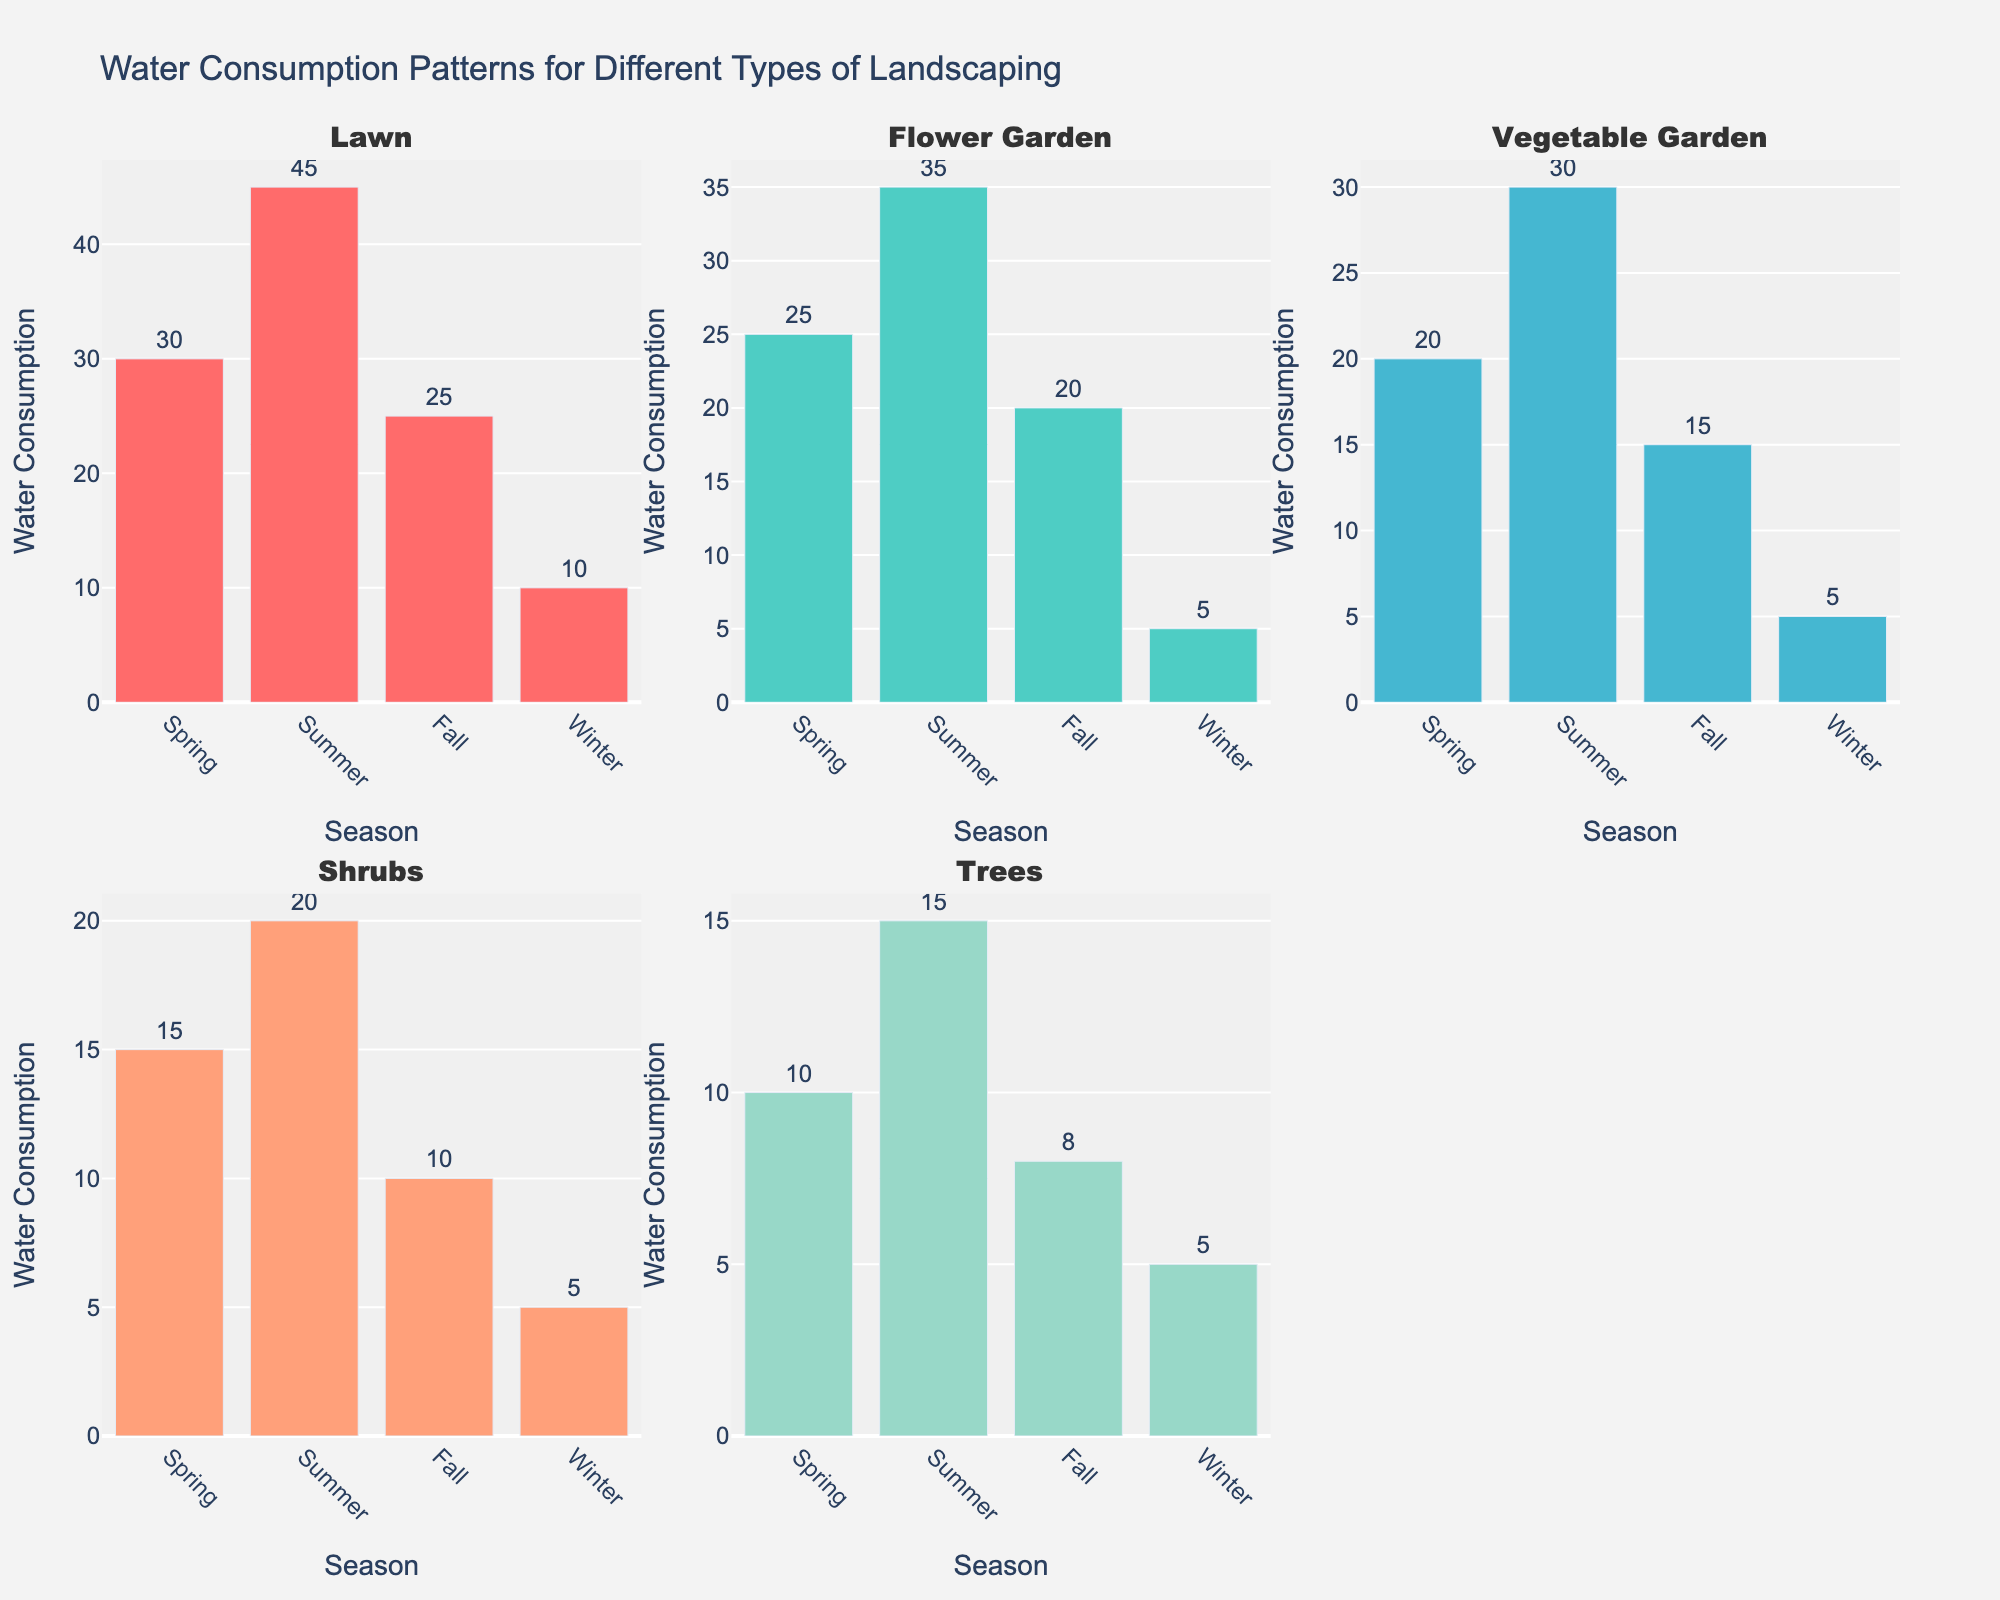What's the title of the figure? The title of the figure is written at the top of the plot and provides an overview of what the figure represents.
Answer: Conviction Rates: Undercover vs Standard Arrests Which crime type has the highest undercover conviction rate? Look at each subplot representing different crime types and identify which has the highest bar for undercover conviction rates. This is Terrorism with a rate of 88%.
Answer: Terrorism Which crime type has the lowest standard arrest conviction rate? Examine the bars representing standard arrest conviction rates in each subplot and find the smallest value. This is Cybercrime with a rate of 55%.
Answer: Cybercrime On average, are conviction rates higher for undercover operations or standard arrests? Look at the heights of the bars in each subplot. Compare the average height of bars for undercover operations to those for standard arrests across all crime types. Undercover conviction rates are consistently higher.
Answer: Undercover operations What's the difference in conviction rates between undercover and standard arrests for Human Trafficking? Look at the subplot for Human Trafficking and subtract the standard arrest conviction rate from the undercover conviction rate (0.80 - 0.58).
Answer: 0.22 or 22% Which crime type has the smallest difference in conviction rates between undercover operations and standard arrests? For each subplot, subtract the standard arrest conviction rate from the undercover conviction rate. The crime type with the lowest difference is Weapons Offenses with a difference of 0.06.
Answer: Weapons Offenses How many crime types have a higher conviction rate for undercover operations compared to standard arrests? Count the number of subplots where the undercover conviction rate bar is higher than the standard arrest conviction rate bar. All subplots fit this criterion, so there are 10 crime types.
Answer: 10 Which crime type shows the largest conviction rate improvement when using undercover operations compared to standard arrests? Calculate the differences for each crime type by subtracting the standard arrest conviction rate from the undercover conviction rate. The highest difference is for Organized Crime with an improvement of 0.25.
Answer: Organized Crime Is there any crime type where standard arrests have a higher conviction rate than undercover operations? Scan through each subplot and compare the heights of the bars. There is no subplot where the standard arrest conviction rate bar is higher than the undercover conviction rate bar.
Answer: No What is the range of standard arrest conviction rates across all crime types? Identify the minimum and maximum values of standard arrest conviction rates from the subplots. The minimum is 55% (Cybercrime) and the maximum is 76% (Terrorism), giving a range of 21 percentage points.
Answer: 21% 